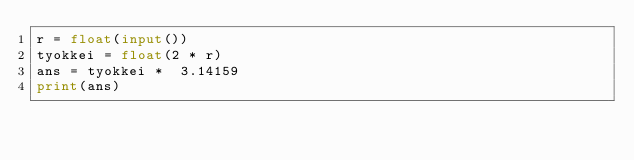<code> <loc_0><loc_0><loc_500><loc_500><_Python_>r = float(input())
tyokkei = float(2 * r)
ans = tyokkei *  3.14159
print(ans)</code> 